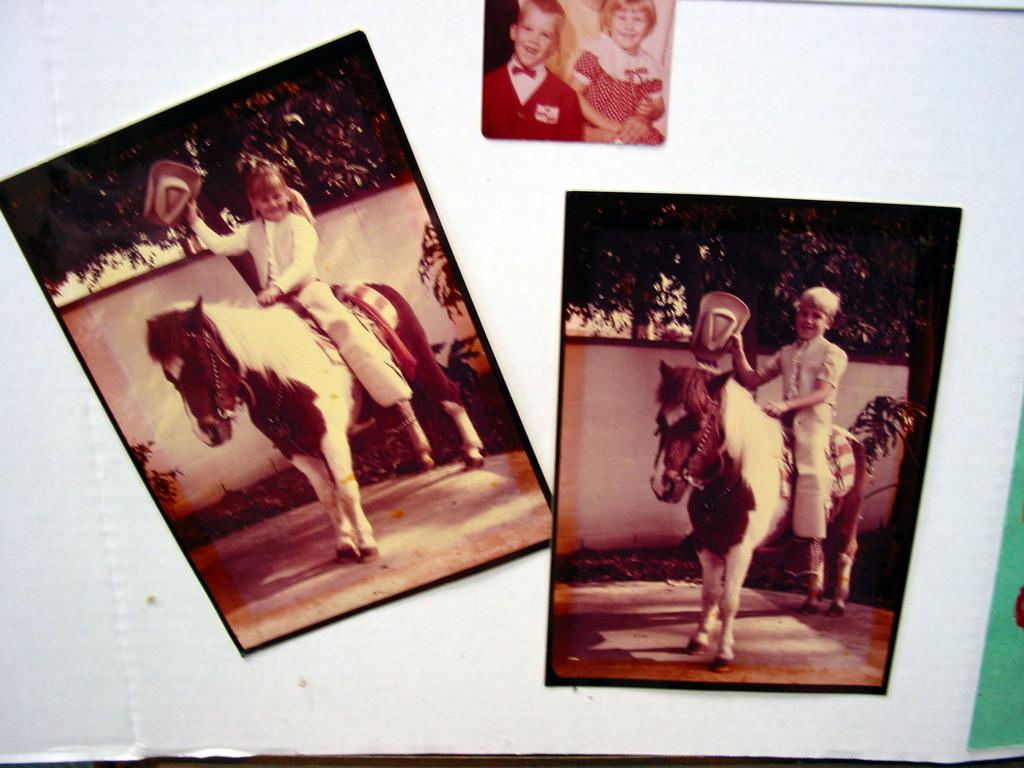How many kids are depicted in the images on the board? There are three images of two kids on the board. What are the kids doing in the first two images? In the first two images, each kid is sitting on a horse individually. How are the kids positioned in the third image? In the third image, the two kids are sitting together on a horse. What type of sink can be seen in the third image? There is no sink present in the third image; it features the two kids sitting together on a horse. What is the condition of the spring in the first image? There is no spring present in the first image; it features one kid sitting on a horse. 